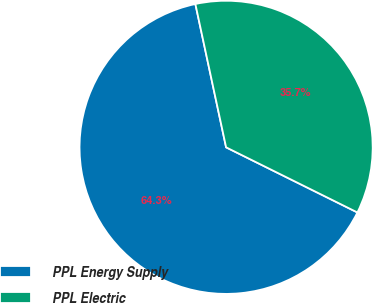<chart> <loc_0><loc_0><loc_500><loc_500><pie_chart><fcel>PPL Energy Supply<fcel>PPL Electric<nl><fcel>64.31%<fcel>35.69%<nl></chart> 